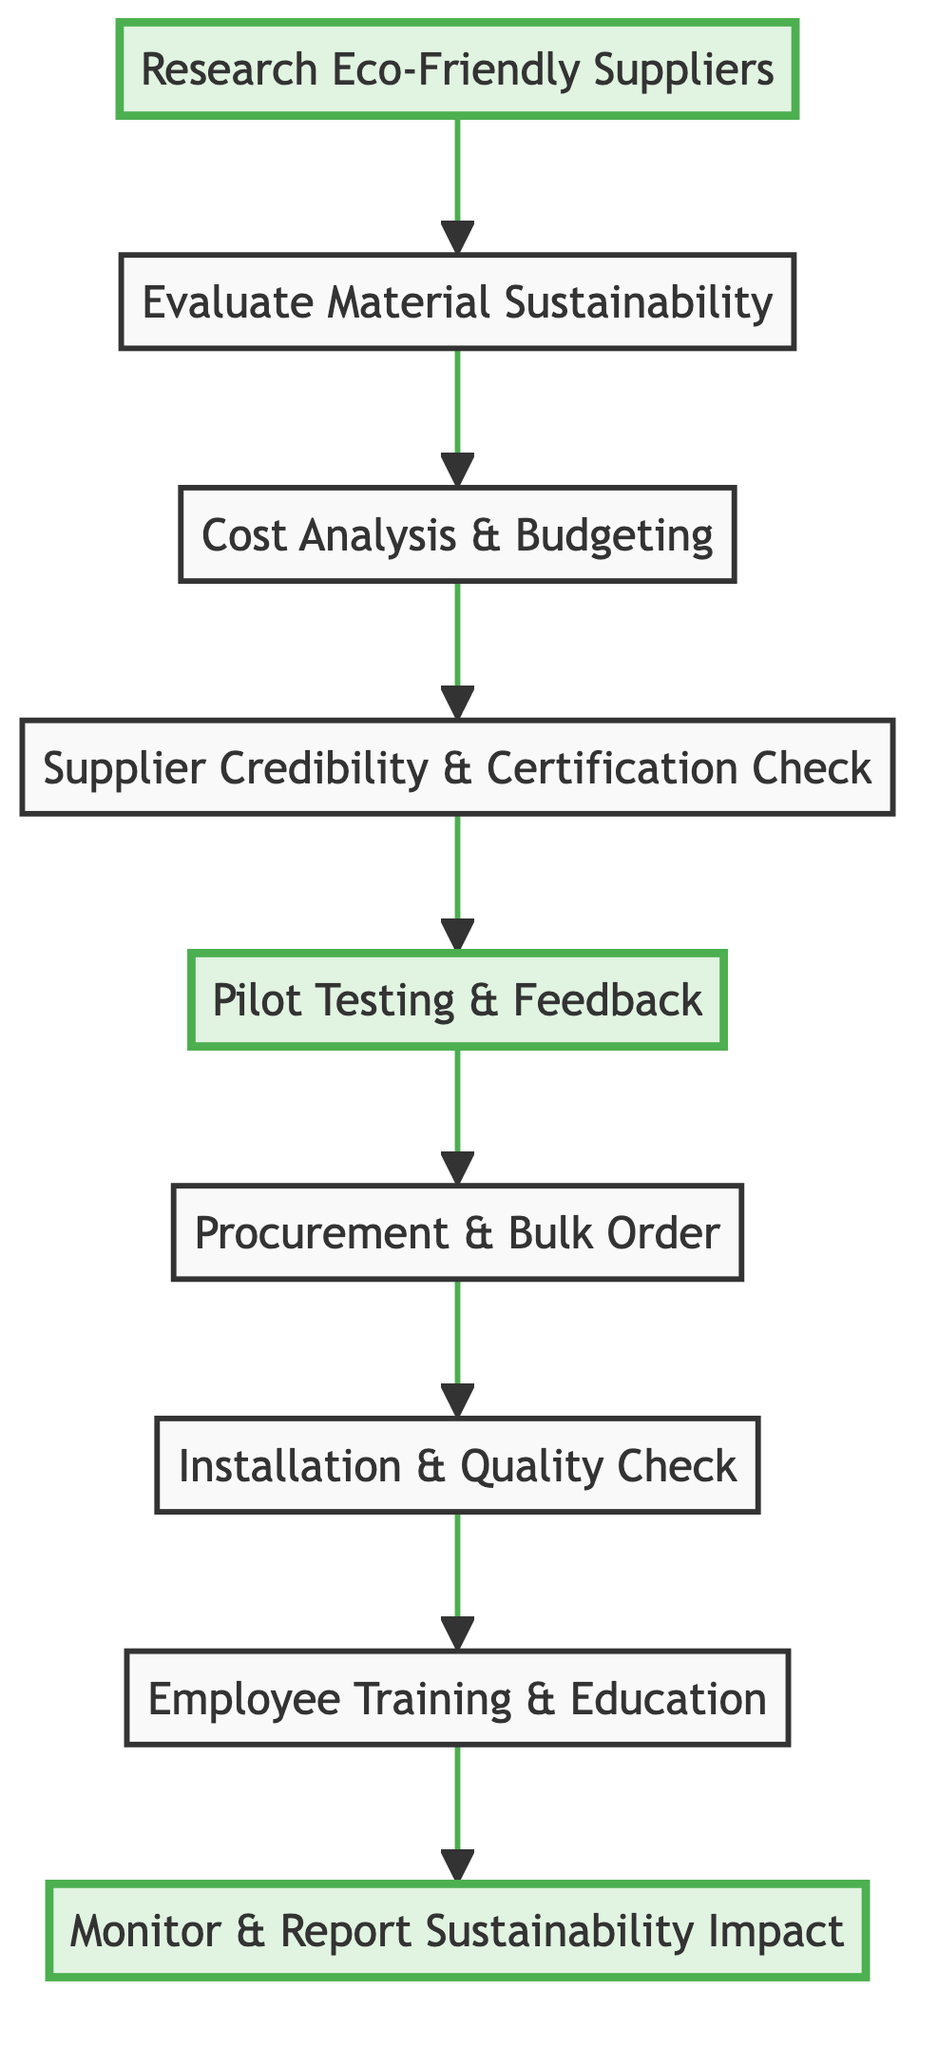What is the first step in the sustainable furniture acquisition process? The first step in the diagram is represented by the node "Research Eco-Friendly Suppliers," which is located at the bottom of the flowchart.
Answer: Research Eco-Friendly Suppliers How many nodes are in the diagram? By counting all the individual elements listed in the flowchart, including the starting and ending nodes, there are a total of nine nodes.
Answer: 9 What comes after Cost Analysis & Budgeting? The diagram shows that after "Cost Analysis & Budgeting," the next node is "Supplier Credibility & Certification Check," indicating the sequential flow from one step to the next.
Answer: Supplier Credibility & Certification Check What are two examples of eco-friendly suppliers mentioned? The chart lists examples under the "Research Eco-Friendly Suppliers" node, specifically naming "Eco Balanza," "Emeco," and "VivaTerra" as its examples.
Answer: Eco Balanza, Emeco Which step focuses on feedback collection? The node labeled "Pilot Testing & Feedback" clearly indicates that this step is dedicated to obtaining feedback from guests and staff after testing the sample furniture.
Answer: Pilot Testing & Feedback What is the last step in the sustainable furniture acquisition process? The final step in the process is indicated by the node "Monitor & Report Sustainability Impact," located at the top of the diagram, portraying it as the concluding action of the flowchart.
Answer: Monitor & Report Sustainability Impact How does "Installation & Quality Check" relate to "Procurement & Bulk Order"? In the flowchart, "Installation & Quality Check" follows "Procurement & Bulk Order," showing a direct relationship where the installation process comes after bulk ordering of the furniture.
Answer: Installation & Quality Check Which steps involve sustainability practices education? The node "Employee Training & Education" is specifically focused on training staff about sustainable practices; it indicates that sustainability education is a key part of implementing the furniture.
Answer: Employee Training & Education What is the purpose of the "Cost Analysis & Budgeting" step? The node clearly describes that this step involves performing a cost analysis to ensure the sustainable furniture fits within the budget, highlighting its financial assessment aspect in the process.
Answer: Cost analysis 